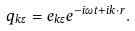<formula> <loc_0><loc_0><loc_500><loc_500>q _ { k \epsilon } = e _ { k \epsilon } e ^ { - i \omega t + i k \cdot r } .</formula> 